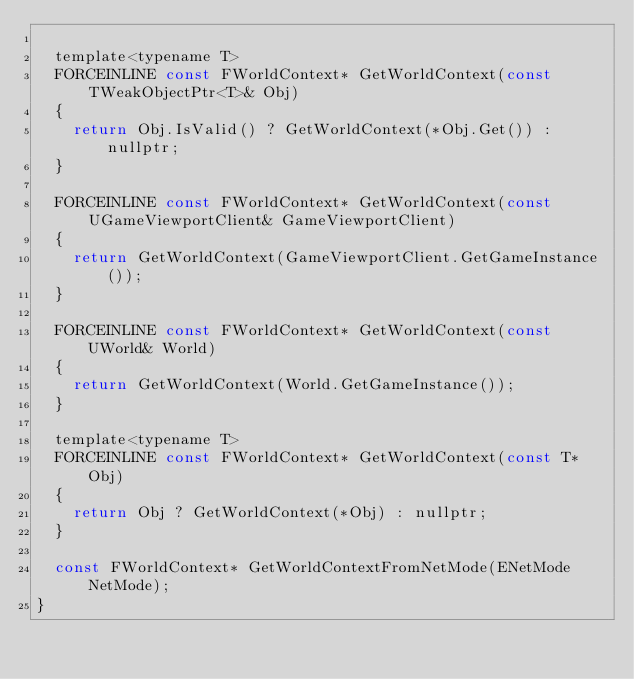Convert code to text. <code><loc_0><loc_0><loc_500><loc_500><_C_>
	template<typename T>
	FORCEINLINE const FWorldContext* GetWorldContext(const TWeakObjectPtr<T>& Obj)
	{
		return Obj.IsValid() ? GetWorldContext(*Obj.Get()) : nullptr;
	}

	FORCEINLINE const FWorldContext* GetWorldContext(const UGameViewportClient& GameViewportClient)
	{
		return GetWorldContext(GameViewportClient.GetGameInstance());
	}

	FORCEINLINE const FWorldContext* GetWorldContext(const UWorld& World)
	{
		return GetWorldContext(World.GetGameInstance());
	}

	template<typename T>
	FORCEINLINE const FWorldContext* GetWorldContext(const T* Obj)
	{
		return Obj ? GetWorldContext(*Obj) : nullptr;
	}

	const FWorldContext* GetWorldContextFromNetMode(ENetMode NetMode);
}
</code> 